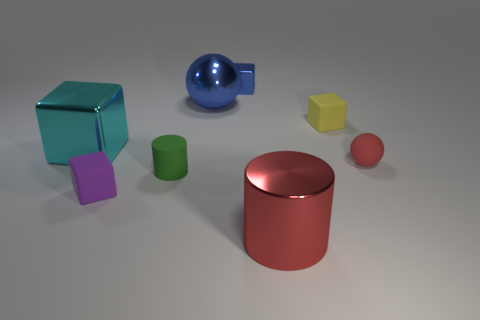Subtract 1 blocks. How many blocks are left? 3 Subtract all purple rubber blocks. How many blocks are left? 3 Subtract all red cubes. Subtract all blue cylinders. How many cubes are left? 4 Add 1 large blue spheres. How many objects exist? 9 Subtract all cylinders. How many objects are left? 6 Subtract all big balls. Subtract all yellow rubber cubes. How many objects are left? 6 Add 5 tiny yellow objects. How many tiny yellow objects are left? 6 Add 3 matte blocks. How many matte blocks exist? 5 Subtract 0 green blocks. How many objects are left? 8 